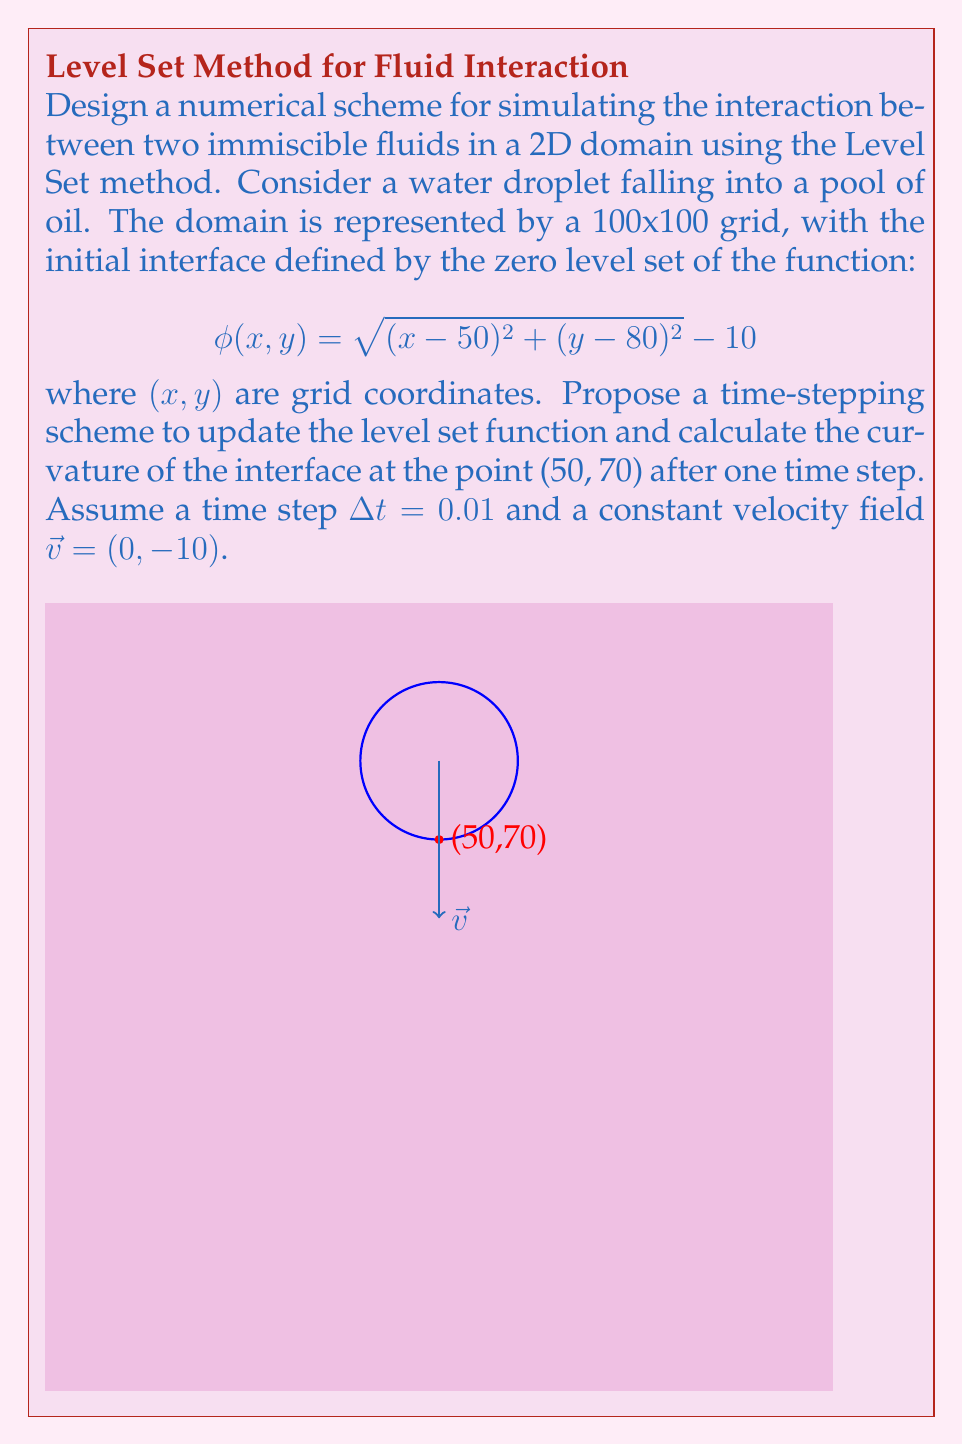Help me with this question. To solve this problem, we'll follow these steps:

1) First, we need to choose a numerical scheme to update the level set function. We'll use the first-order upwind scheme for spatial discretization and forward Euler for time integration.

2) The level set equation is:

   $$\frac{\partial \phi}{\partial t} + \vec{v} \cdot \nabla \phi = 0$$

3) Using the upwind scheme, we discretize this as:

   $$\frac{\phi^{n+1}_{i,j} - \phi^n_{i,j}}{\Delta t} + \max(v_x, 0)\frac{\phi^n_{i,j} - \phi^n_{i-1,j}}{\Delta x} + \min(v_x, 0)\frac{\phi^n_{i+1,j} - \phi^n_{i,j}}{\Delta x} + \max(v_y, 0)\frac{\phi^n_{i,j} - \phi^n_{i,j-1}}{\Delta y} + \min(v_y, 0)\frac{\phi^n_{i,j+1} - \phi^n_{i,j}}{\Delta y} = 0$$

4) Given $\vec{v} = (0, -10)$, this simplifies to:

   $$\frac{\phi^{n+1}_{i,j} - \phi^n_{i,j}}{\Delta t} + 10\frac{\phi^n_{i,j+1} - \phi^n_{i,j}}{\Delta y} = 0$$

5) Rearranging for $\phi^{n+1}_{i,j}$:

   $$\phi^{n+1}_{i,j} = \phi^n_{i,j} - 10\frac{\Delta t}{\Delta y}(\phi^n_{i,j+1} - \phi^n_{i,j})$$

6) To calculate the curvature, we use the formula:

   $$\kappa = \nabla \cdot \frac{\nabla \phi}{|\nabla \phi|}$$

7) We can approximate this using central differences:

   $$\kappa_{i,j} \approx \frac{\phi_{xx}(1+\phi_y^2) + \phi_{yy}(1+\phi_x^2) - 2\phi_x\phi_y\phi_{xy}}{(1+\phi_x^2+\phi_y^2)^{3/2}}$$

   where $\phi_x$, $\phi_y$, $\phi_{xx}$, $\phi_{yy}$, and $\phi_{xy}$ are approximated using central differences.

8) At the point (50, 70), we need to calculate these derivatives after one time step. First, update $\phi$ using the scheme from step 5, then calculate the derivatives and curvature.
Answer: Updated level set function: $\phi^{n+1}_{i,j} = \phi^n_{i,j} - 10\frac{\Delta t}{\Delta y}(\phi^n_{i,j+1} - \phi^n_{i,j})$

Curvature: $\kappa = \frac{\phi_{xx}(1+\phi_y^2) + \phi_{yy}(1+\phi_x^2) - 2\phi_x\phi_y\phi_{xy}}{(1+\phi_x^2+\phi_y^2)^{3/2}}$ at (50, 70) 